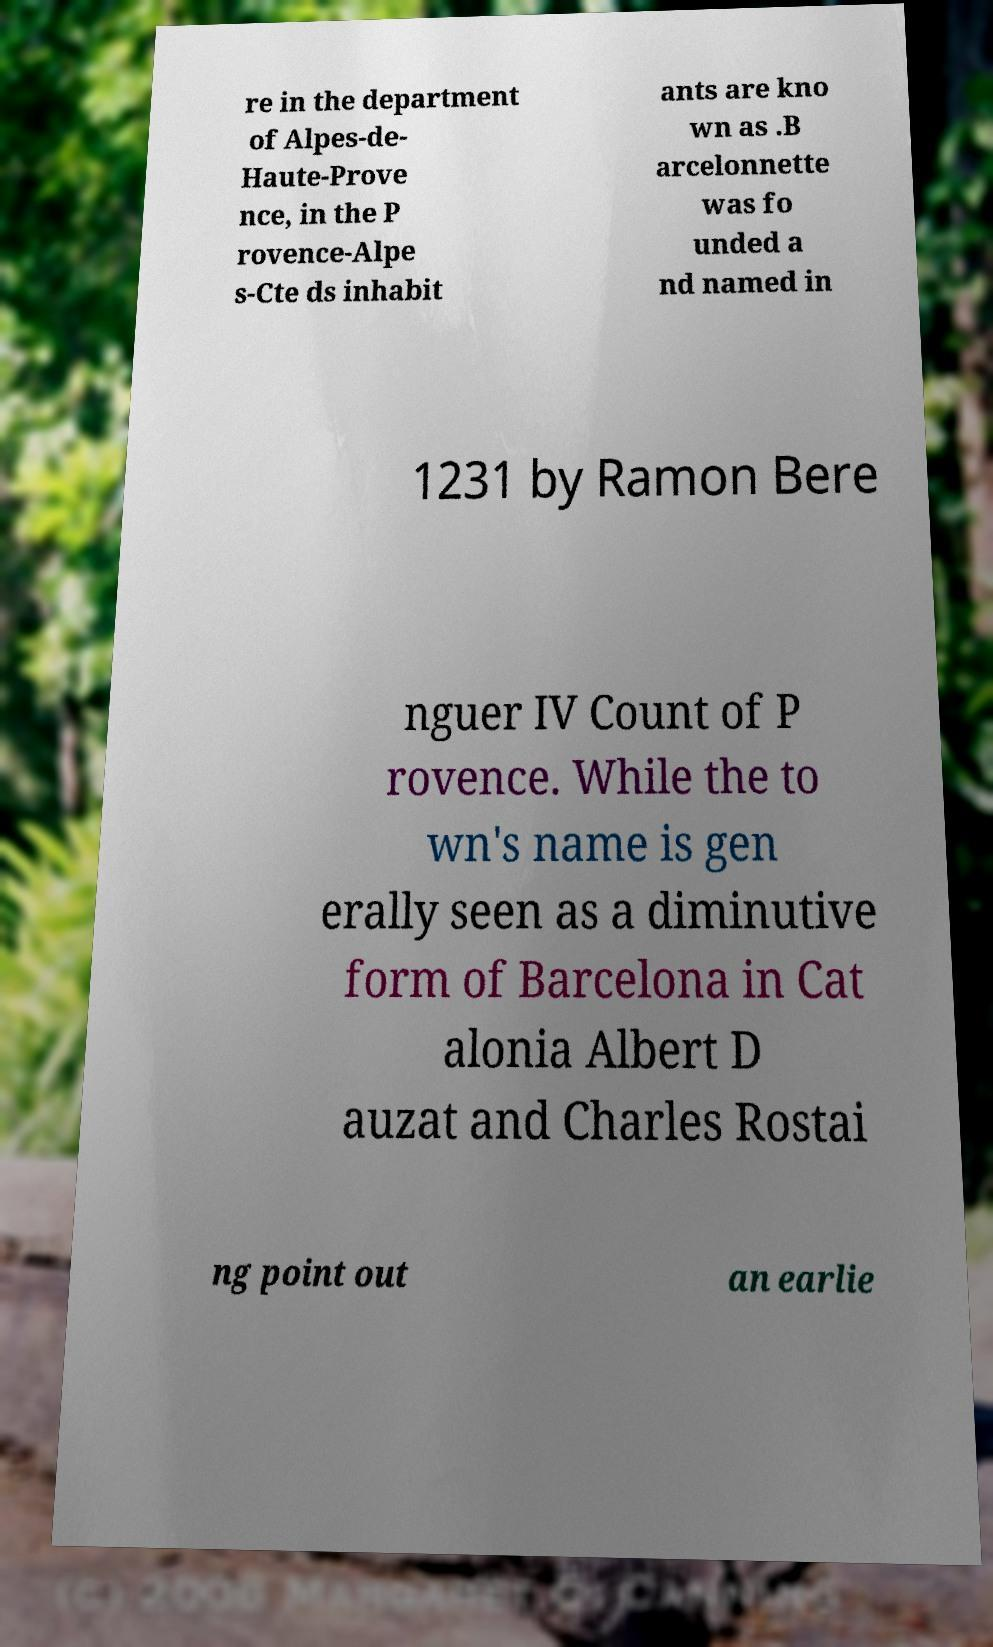Could you assist in decoding the text presented in this image and type it out clearly? re in the department of Alpes-de- Haute-Prove nce, in the P rovence-Alpe s-Cte ds inhabit ants are kno wn as .B arcelonnette was fo unded a nd named in 1231 by Ramon Bere nguer IV Count of P rovence. While the to wn's name is gen erally seen as a diminutive form of Barcelona in Cat alonia Albert D auzat and Charles Rostai ng point out an earlie 